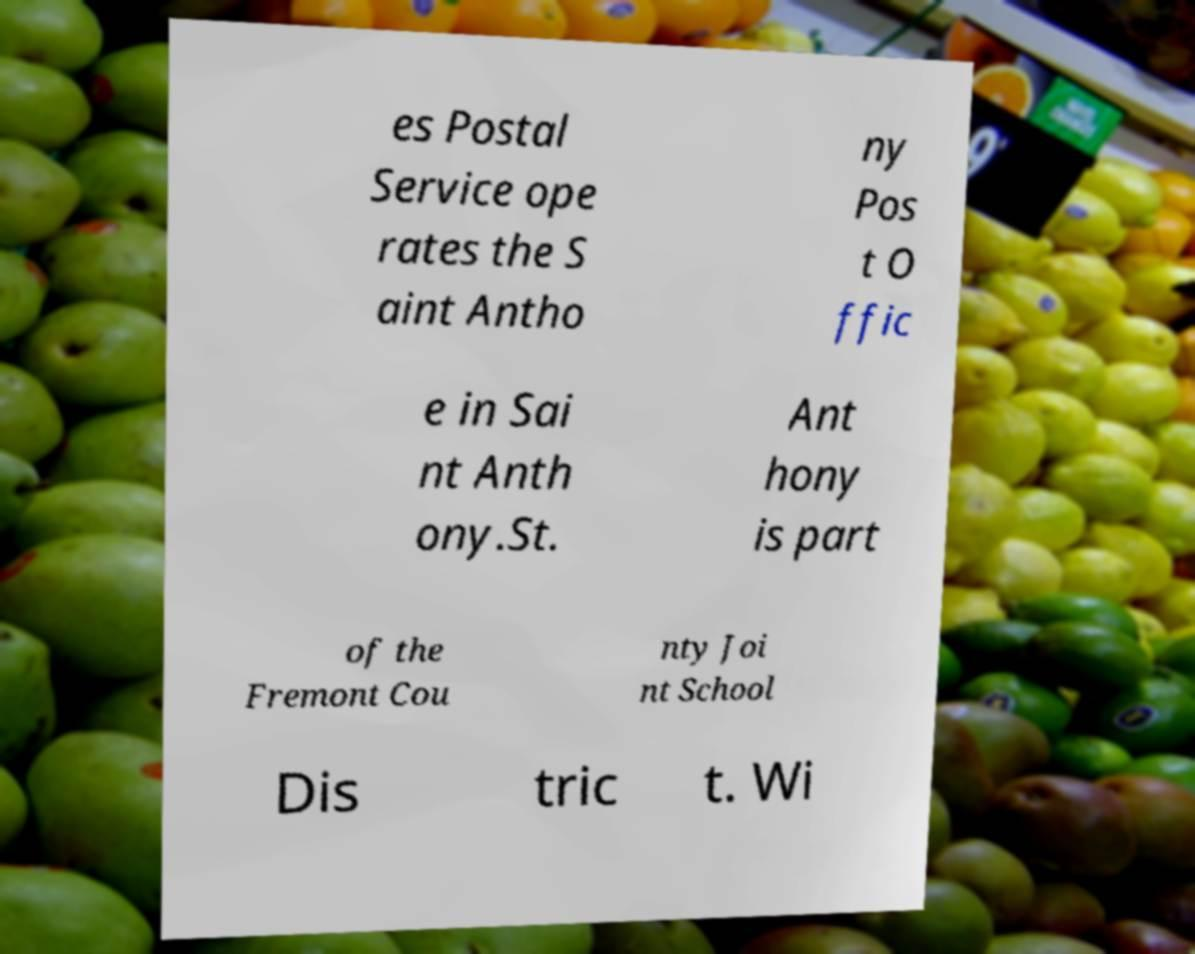I need the written content from this picture converted into text. Can you do that? es Postal Service ope rates the S aint Antho ny Pos t O ffic e in Sai nt Anth ony.St. Ant hony is part of the Fremont Cou nty Joi nt School Dis tric t. Wi 